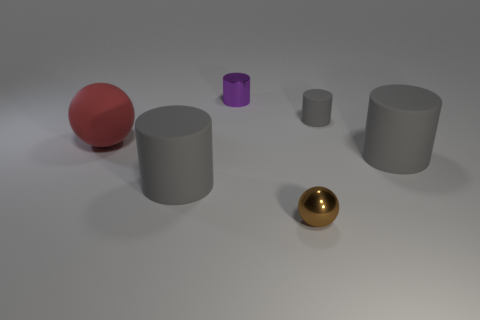Are there any cylinders that have the same size as the rubber sphere?
Provide a succinct answer. Yes. How many objects are either gray cylinders right of the tiny shiny ball or large gray shiny things?
Offer a terse response. 2. Is the material of the small purple cylinder the same as the sphere that is in front of the red matte ball?
Provide a short and direct response. Yes. What number of other objects are there of the same shape as the small rubber thing?
Provide a short and direct response. 3. What number of objects are things that are to the left of the tiny purple metallic object or small objects that are right of the small purple thing?
Your response must be concise. 4. What number of other objects are the same color as the metal ball?
Provide a succinct answer. 0. Are there fewer brown shiny balls that are on the left side of the small shiny ball than purple metal objects that are behind the purple metallic object?
Your answer should be compact. No. What number of large gray rubber cubes are there?
Give a very brief answer. 0. Is there any other thing that has the same material as the brown sphere?
Keep it short and to the point. Yes. What is the material of the big object that is the same shape as the small brown thing?
Give a very brief answer. Rubber. 